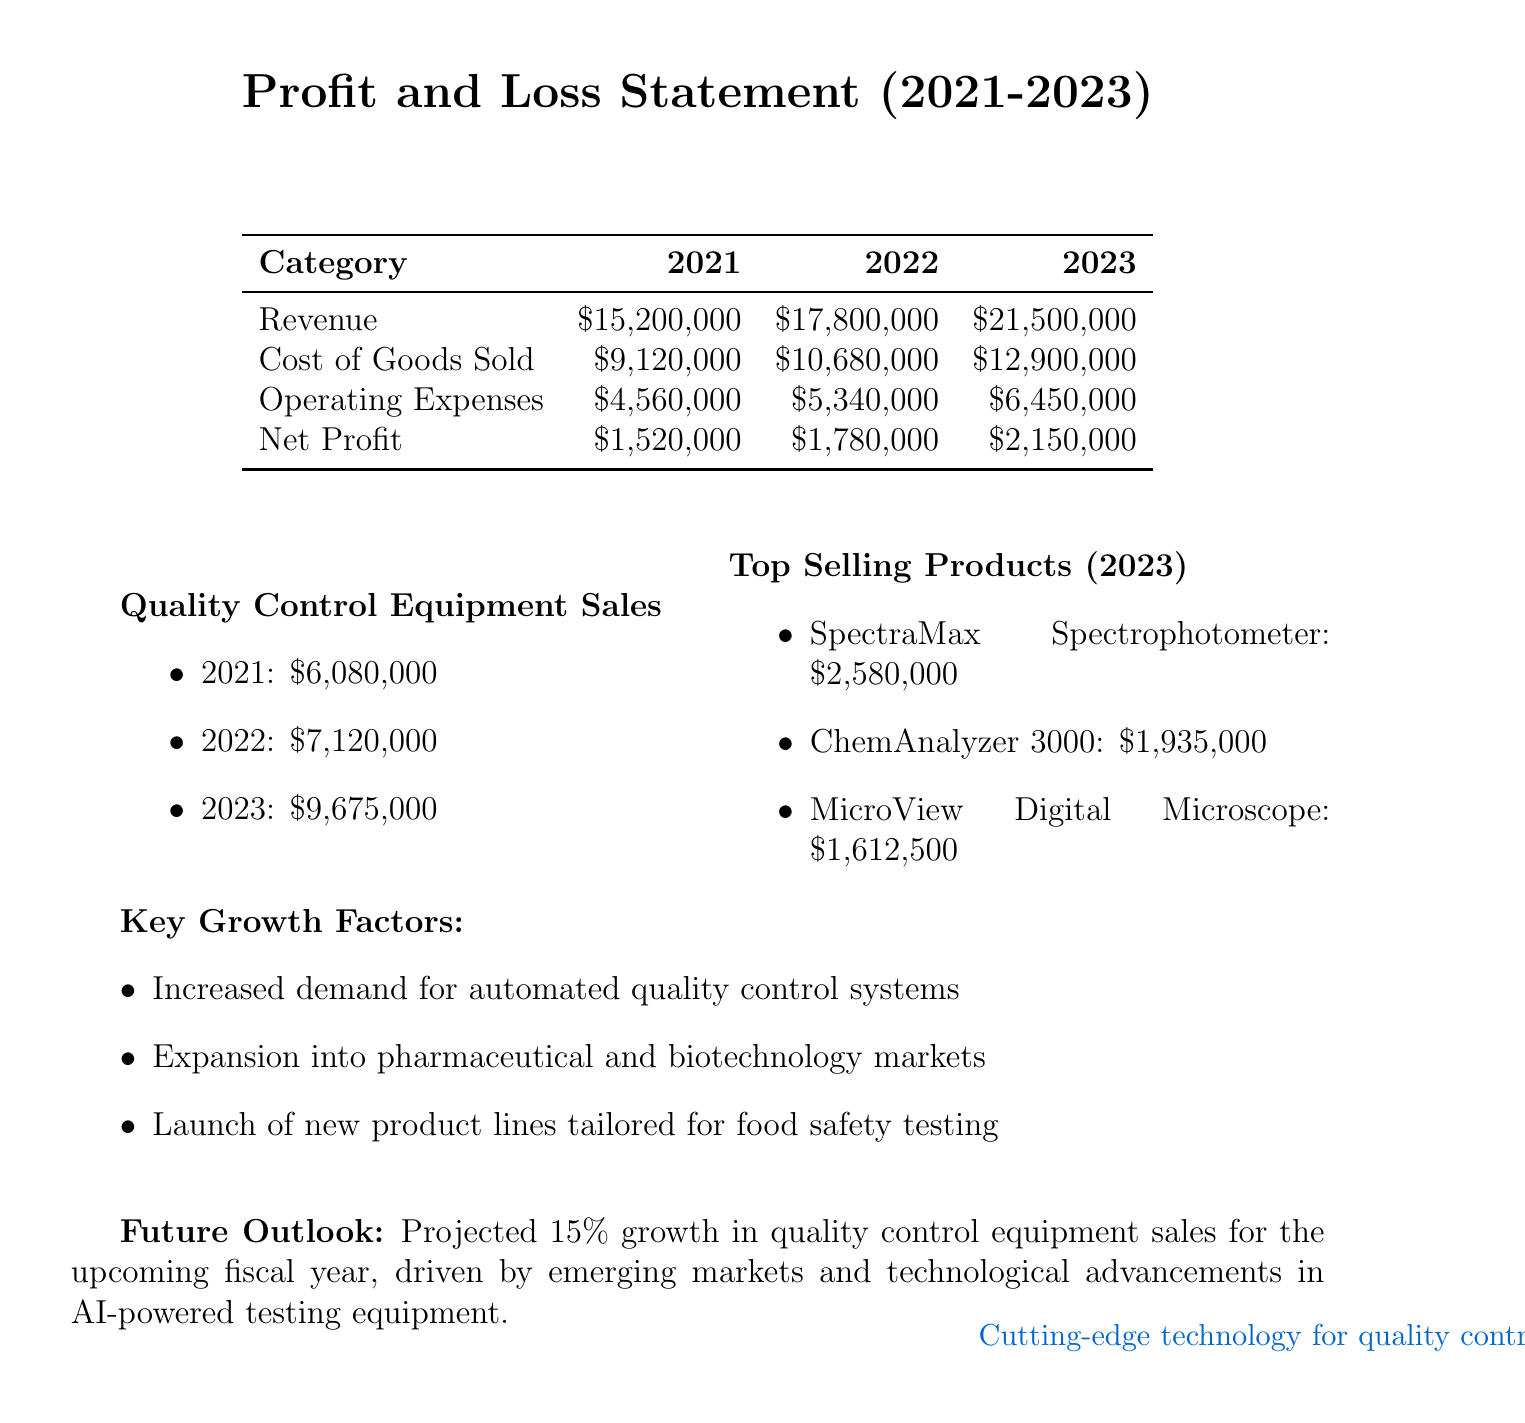What is the revenue for 2023? The revenue for 2023 is mentioned clearly in the document as $21,500,000.
Answer: $21,500,000 What was the net profit in 2022? The net profit for 2022 is provided in the financial table as $1,780,000.
Answer: $1,780,000 How much did quality control equipment sales grow from 2022 to 2023? The difference between the sales in 2022 ($7,120,000) and 2023 ($9,675,000) indicates a growth of $2,555,000.
Answer: $2,555,000 What was the total operating expenses in 2021? The total operating expenses for 2021 are stated in the document as $4,560,000.
Answer: $4,560,000 Which product had the highest sales in 2023? The product with the highest sales in 2023 is the SpectraMax Spectrophotometer, listed at $2,580,000.
Answer: SpectraMax Spectrophotometer What percentage of growth is projected for the upcoming fiscal year in quality control equipment sales? The document outlines a projected growth rate of 15% for the forthcoming fiscal year.
Answer: 15% List one key growth factor mentioned. The document highlights multiple factors; one is "Increased demand for automated quality control systems."
Answer: Increased demand for automated quality control systems What two categories are included in the profit and loss statement? The profit and loss statement includes various categories, notably Revenue and Net Profit.
Answer: Revenue and Net Profit What is the fiscal year range provided in the report? The fiscal years covered in the report span from 2021 to 2023.
Answer: 2021 to 2023 